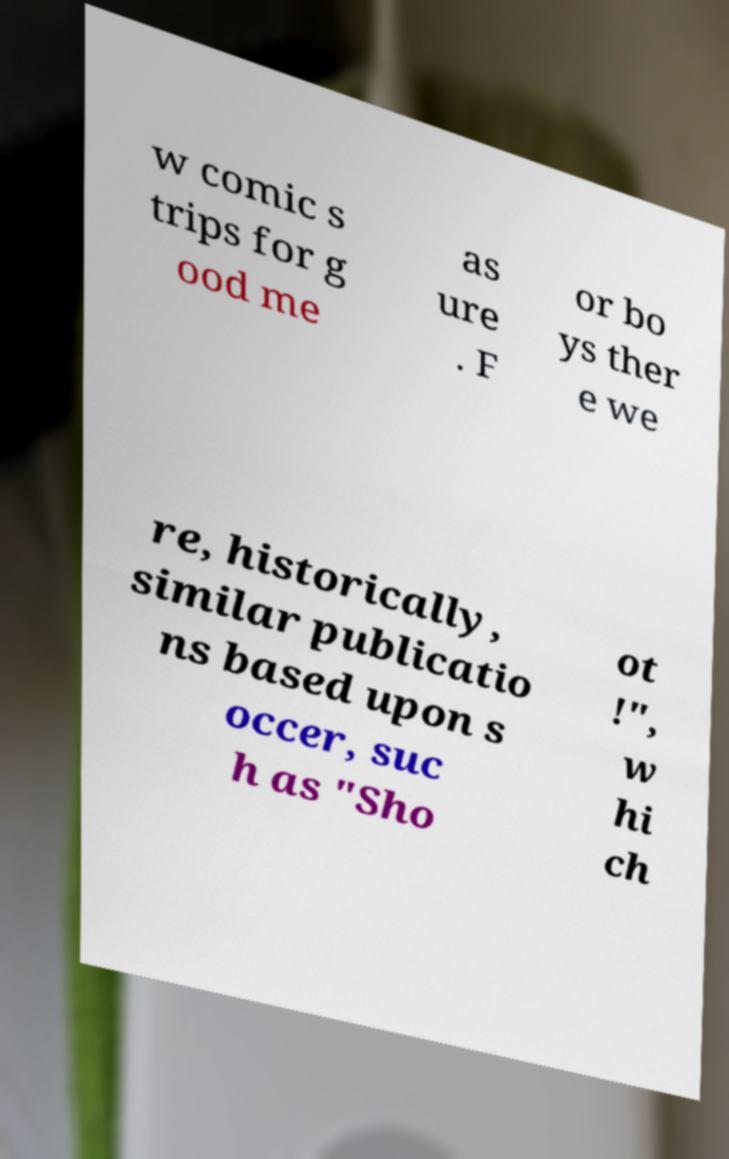Can you read and provide the text displayed in the image?This photo seems to have some interesting text. Can you extract and type it out for me? w comic s trips for g ood me as ure . F or bo ys ther e we re, historically, similar publicatio ns based upon s occer, suc h as "Sho ot !", w hi ch 